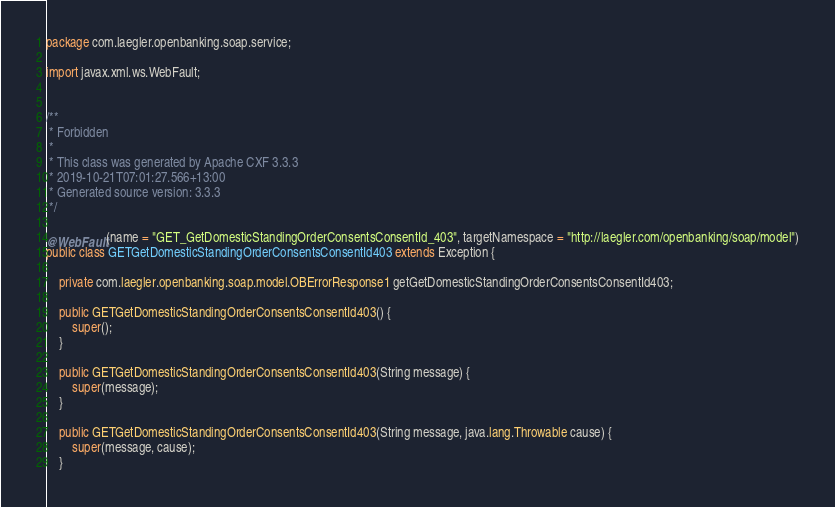Convert code to text. <code><loc_0><loc_0><loc_500><loc_500><_Java_>
package com.laegler.openbanking.soap.service;

import javax.xml.ws.WebFault;


/**
 * Forbidden
 *
 * This class was generated by Apache CXF 3.3.3
 * 2019-10-21T07:01:27.566+13:00
 * Generated source version: 3.3.3
 */

@WebFault(name = "GET_GetDomesticStandingOrderConsentsConsentId_403", targetNamespace = "http://laegler.com/openbanking/soap/model")
public class GETGetDomesticStandingOrderConsentsConsentId403 extends Exception {

    private com.laegler.openbanking.soap.model.OBErrorResponse1 getGetDomesticStandingOrderConsentsConsentId403;

    public GETGetDomesticStandingOrderConsentsConsentId403() {
        super();
    }

    public GETGetDomesticStandingOrderConsentsConsentId403(String message) {
        super(message);
    }

    public GETGetDomesticStandingOrderConsentsConsentId403(String message, java.lang.Throwable cause) {
        super(message, cause);
    }
</code> 